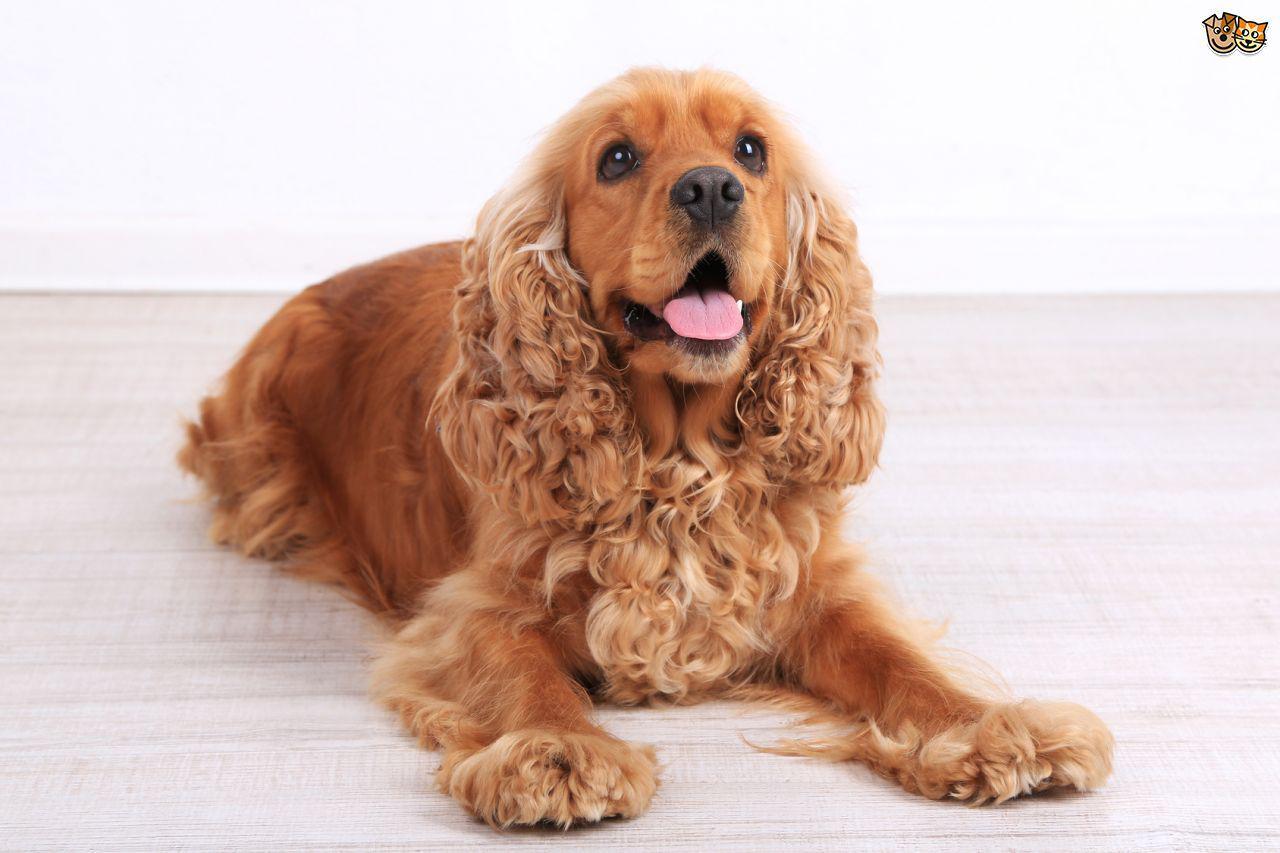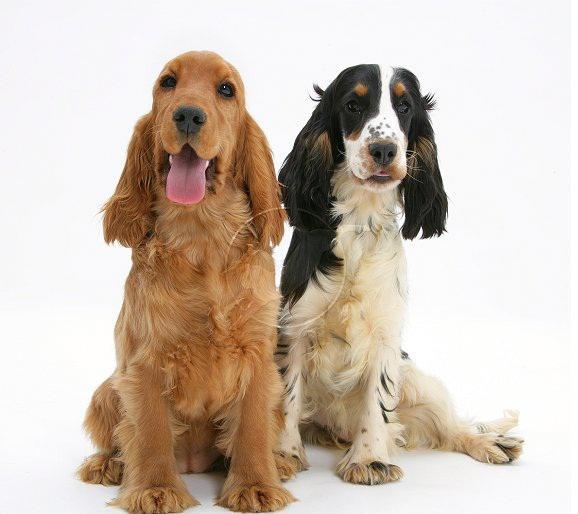The first image is the image on the left, the second image is the image on the right. Analyze the images presented: Is the assertion "there are 3 dogs in the image pair" valid? Answer yes or no. Yes. The first image is the image on the left, the second image is the image on the right. Given the left and right images, does the statement "There are a total of 4 dogs present." hold true? Answer yes or no. No. 